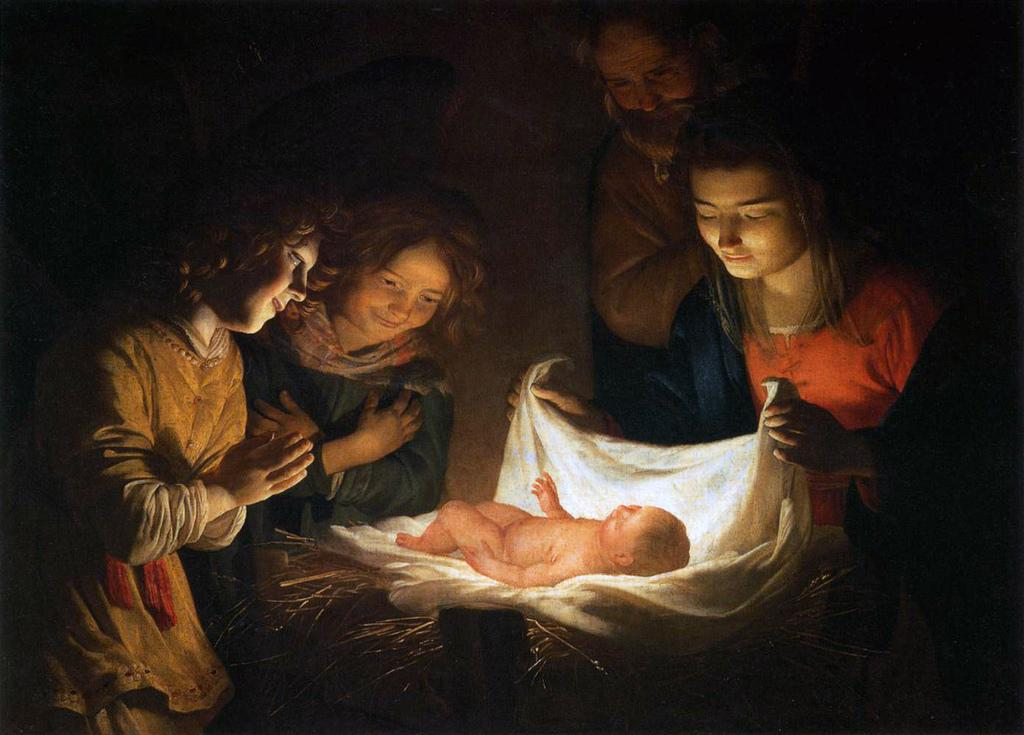What is the main subject of the image? There is a painting in the image. What is happening in the painting? The painting depicts people standing and looking towards a baby. How is the baby positioned in the painting? The baby is on a cloth. Who is holding the cloth in the painting? A girl is holding the cloth. How many rabbits are hopping around the baby in the painting? There are no rabbits present in the painting; it only features people, a baby, a cloth, and a girl holding the cloth. 